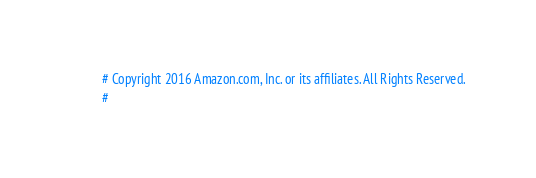Convert code to text. <code><loc_0><loc_0><loc_500><loc_500><_Python_># Copyright 2016 Amazon.com, Inc. or its affiliates. All Rights Reserved.
#</code> 